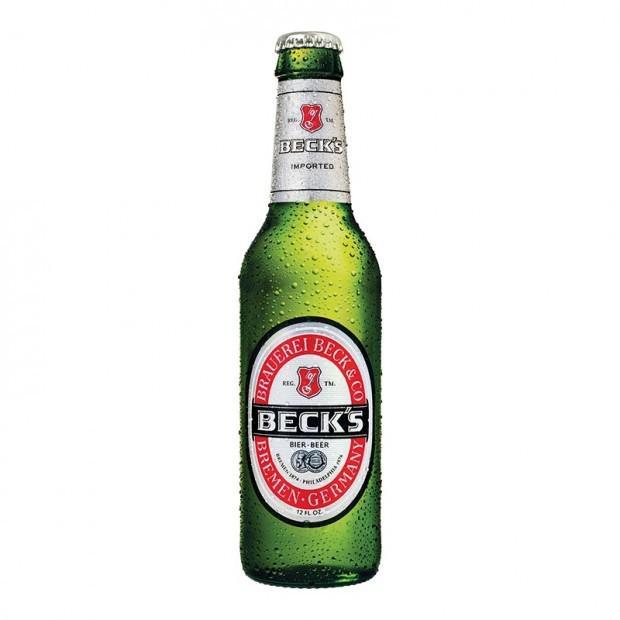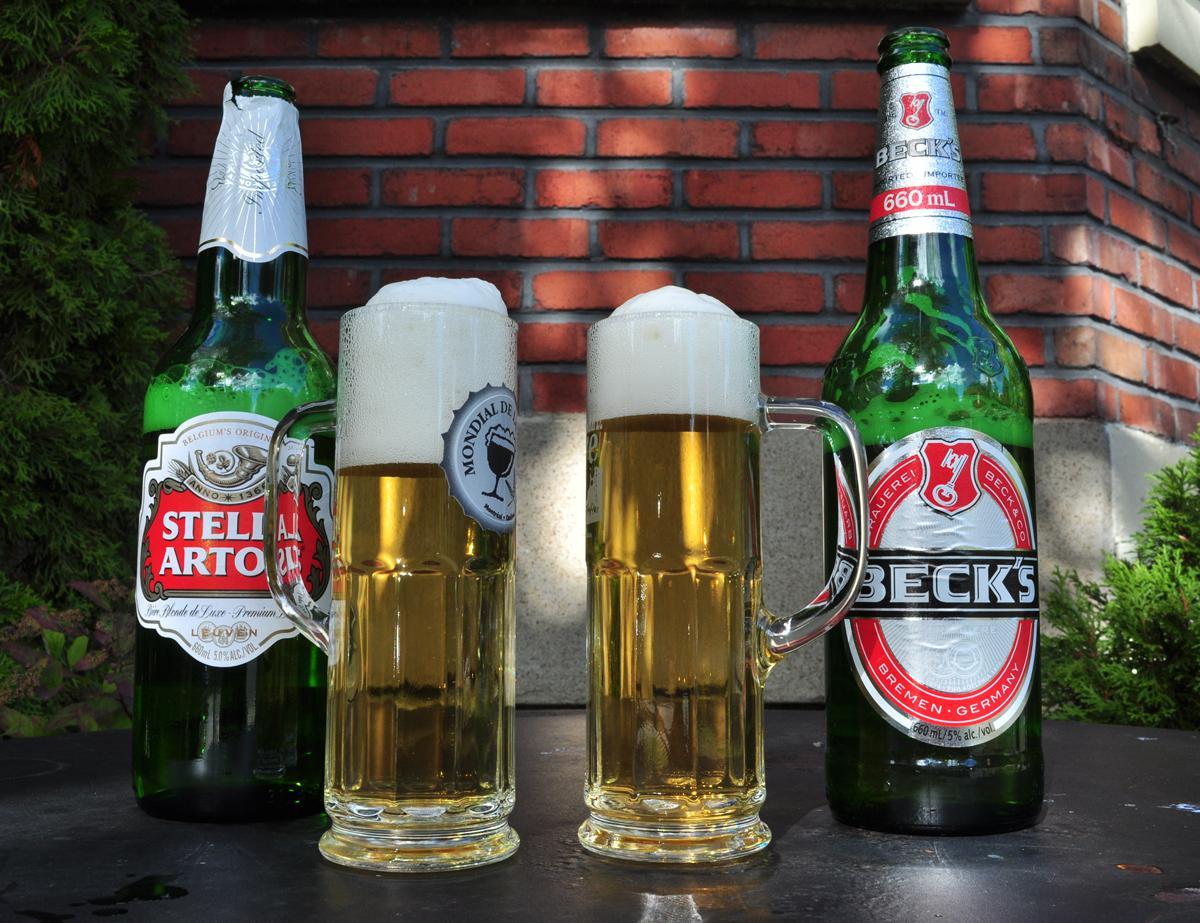The first image is the image on the left, the second image is the image on the right. Analyze the images presented: Is the assertion "Some of the beer is served in a glass, and some is still in bottles." valid? Answer yes or no. Yes. The first image is the image on the left, the second image is the image on the right. Given the left and right images, does the statement "Four or fewer beer bottles are visible." hold true? Answer yes or no. Yes. 